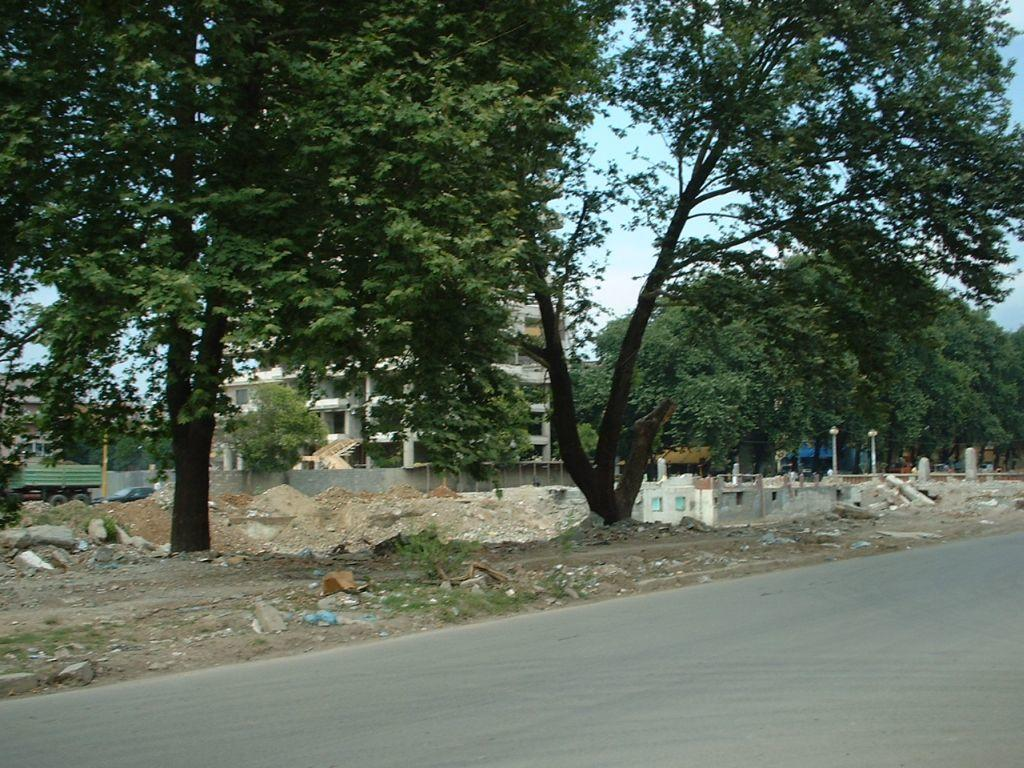What type of vegetation can be seen beside the road in the image? There are trees beside the road in the image. What structure is located in the middle of the image? There is a building in the middle of the image. What can be seen on the left side of the image? There is a vehicle on the left side of the image. How many brothers are playing baseball with the bears in the image? There are no brothers, baseball, or bears present in the image. 